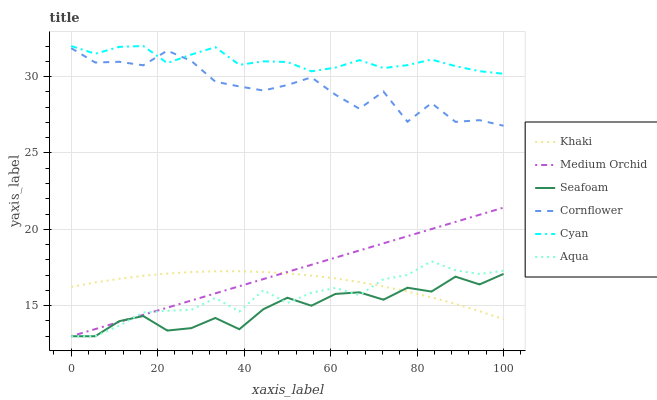Does Seafoam have the minimum area under the curve?
Answer yes or no. Yes. Does Cyan have the maximum area under the curve?
Answer yes or no. Yes. Does Khaki have the minimum area under the curve?
Answer yes or no. No. Does Khaki have the maximum area under the curve?
Answer yes or no. No. Is Medium Orchid the smoothest?
Answer yes or no. Yes. Is Cornflower the roughest?
Answer yes or no. Yes. Is Khaki the smoothest?
Answer yes or no. No. Is Khaki the roughest?
Answer yes or no. No. Does Khaki have the lowest value?
Answer yes or no. No. Does Khaki have the highest value?
Answer yes or no. No. Is Khaki less than Cyan?
Answer yes or no. Yes. Is Cornflower greater than Aqua?
Answer yes or no. Yes. Does Khaki intersect Cyan?
Answer yes or no. No. 